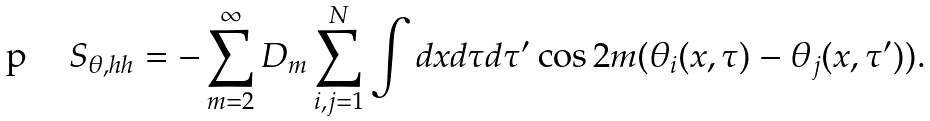<formula> <loc_0><loc_0><loc_500><loc_500>S _ { \theta , h h } = - \sum _ { m = 2 } ^ { \infty } D _ { m } \sum _ { i , j = 1 } ^ { N } \int d x d \tau d \tau ^ { \prime } \cos 2 m ( \theta _ { i } ( x , \tau ) - \theta _ { j } ( x , \tau ^ { \prime } ) ) .</formula> 